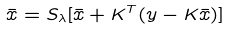Convert formula to latex. <formula><loc_0><loc_0><loc_500><loc_500>\bar { x } = S _ { \lambda } [ \bar { x } + K ^ { T } ( y - K \bar { x } ) ]</formula> 